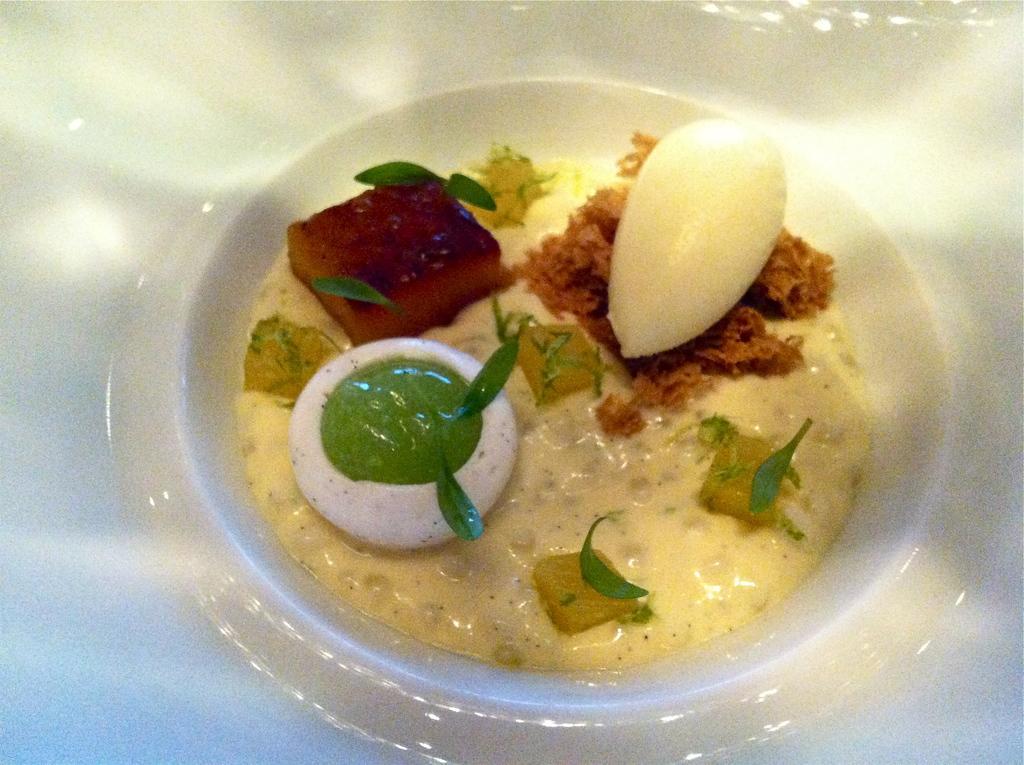Please provide a concise description of this image. In this image, I can see food items in a plate. 